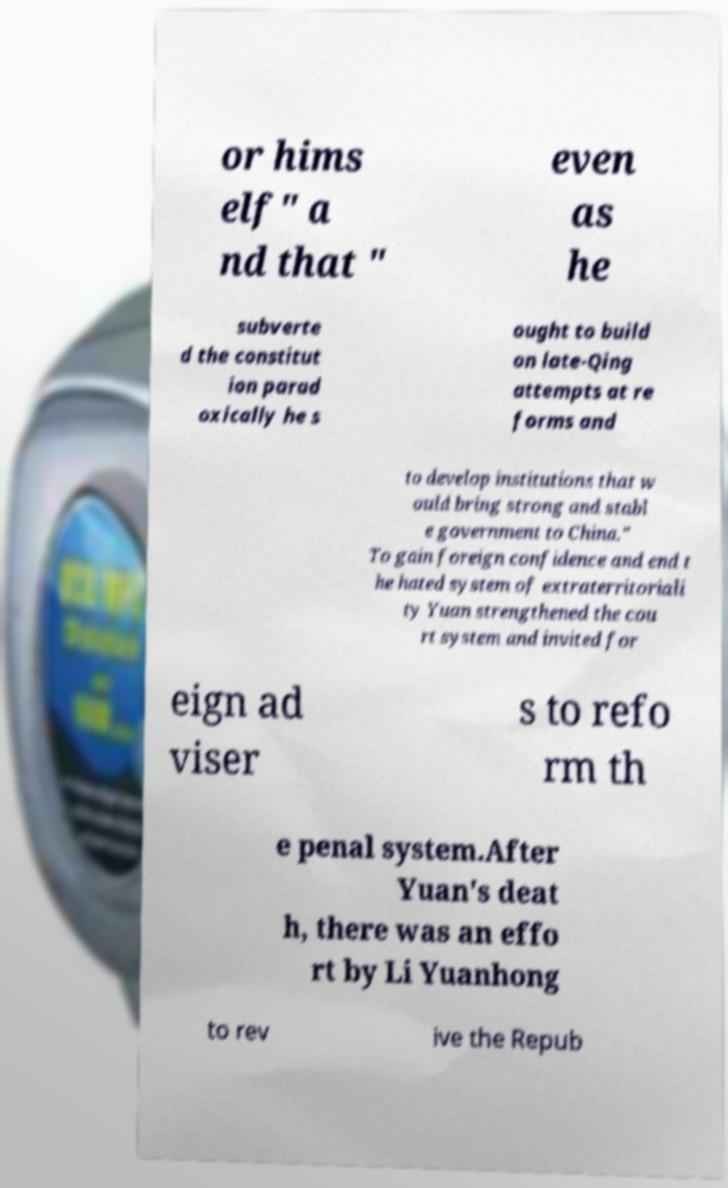What messages or text are displayed in this image? I need them in a readable, typed format. or hims elf" a nd that " even as he subverte d the constitut ion parad oxically he s ought to build on late-Qing attempts at re forms and to develop institutions that w ould bring strong and stabl e government to China." To gain foreign confidence and end t he hated system of extraterritoriali ty Yuan strengthened the cou rt system and invited for eign ad viser s to refo rm th e penal system.After Yuan's deat h, there was an effo rt by Li Yuanhong to rev ive the Repub 